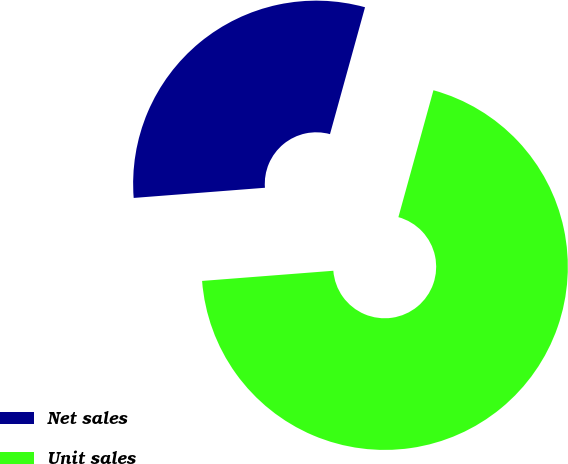Convert chart. <chart><loc_0><loc_0><loc_500><loc_500><pie_chart><fcel>Net sales<fcel>Unit sales<nl><fcel>30.52%<fcel>69.48%<nl></chart> 